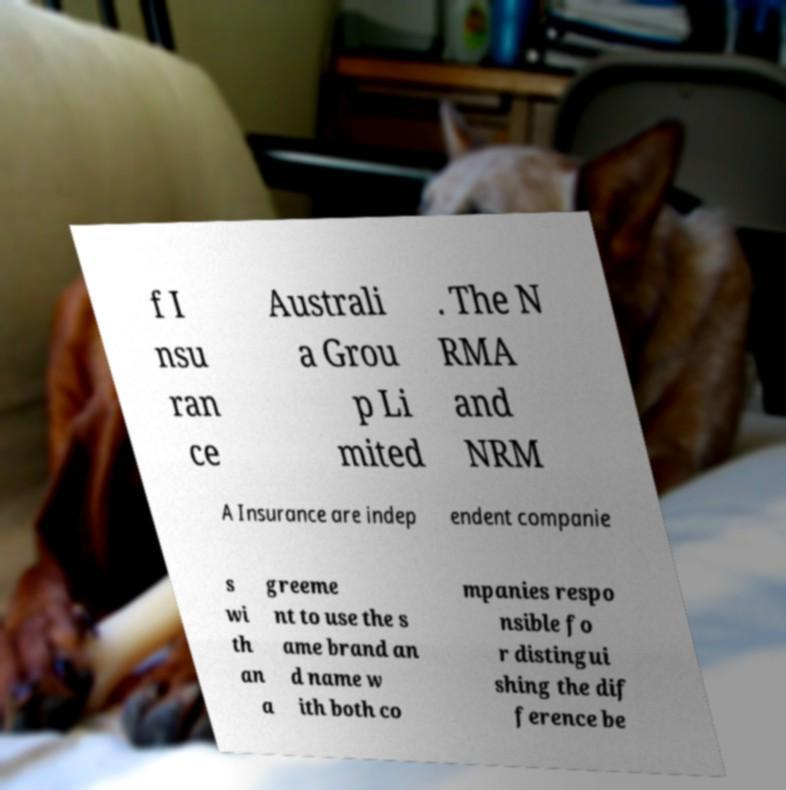There's text embedded in this image that I need extracted. Can you transcribe it verbatim? f I nsu ran ce Australi a Grou p Li mited . The N RMA and NRM A Insurance are indep endent companie s wi th an a greeme nt to use the s ame brand an d name w ith both co mpanies respo nsible fo r distingui shing the dif ference be 